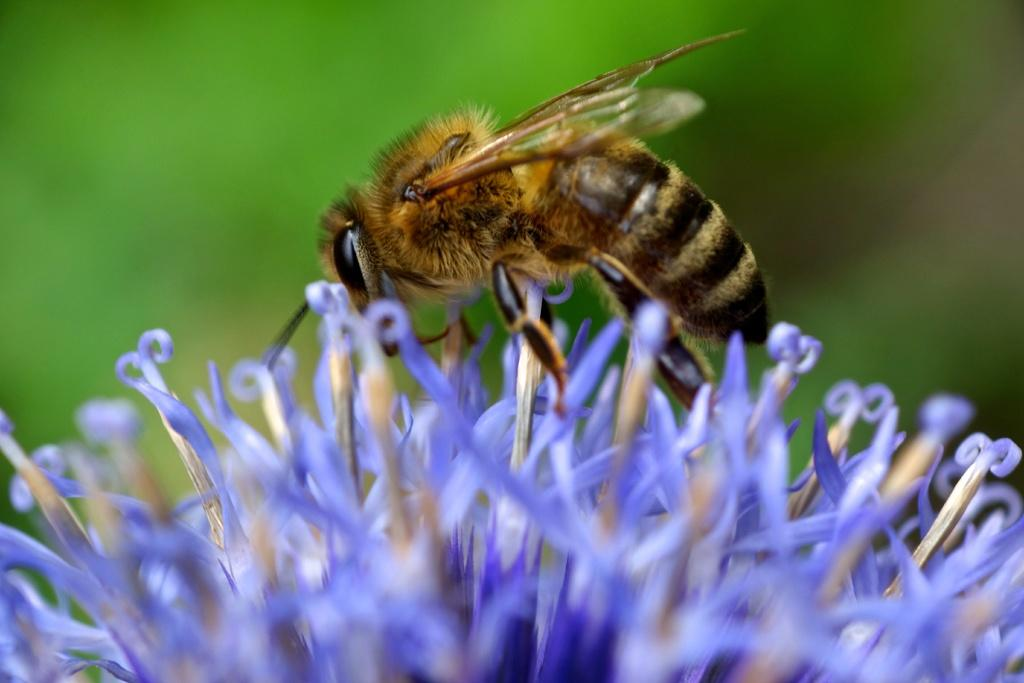What is the main subject of the image? There is a honey bee in the image. What is the honey bee doing in the image? The honey bee is standing on a flower. What can be seen in the background of the image? There are trees visible in the background of the image. What type of spoon is the honey bee using to collect nectar from the flower? There is no spoon present in the image, and honey bees do not use spoons to collect nectar; they use their proboscis. 